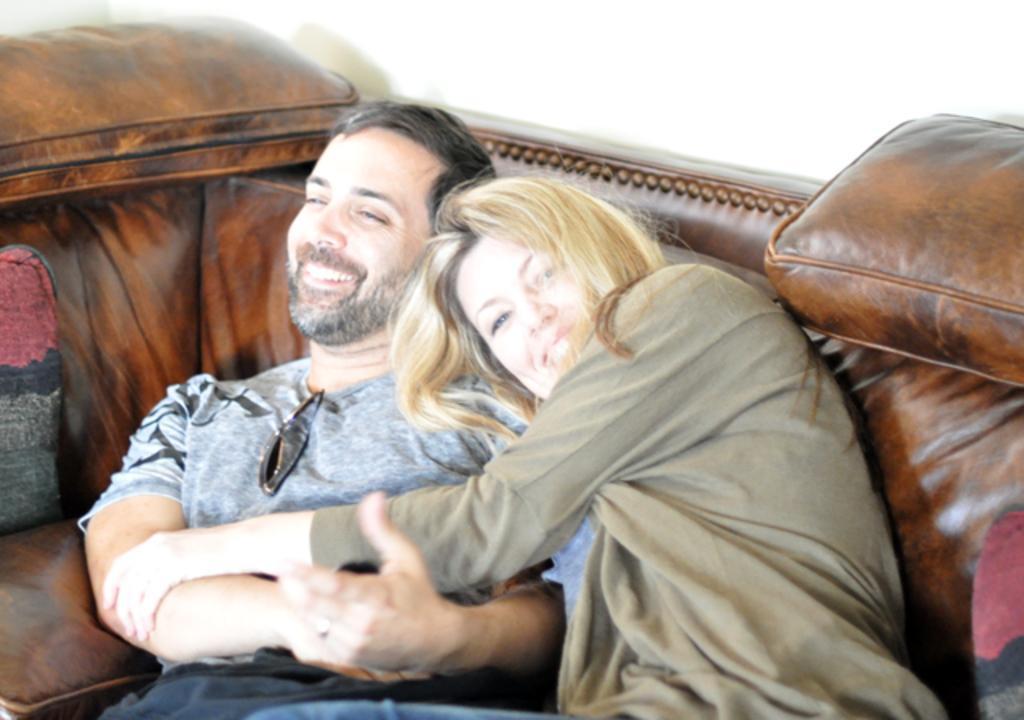Could you give a brief overview of what you see in this image? In this image I can see two persons, the person at right is wearing green color shirt and the person at left is wearing gray color shirt and I can see the couch in brown color. In the background the wall is in white color. 